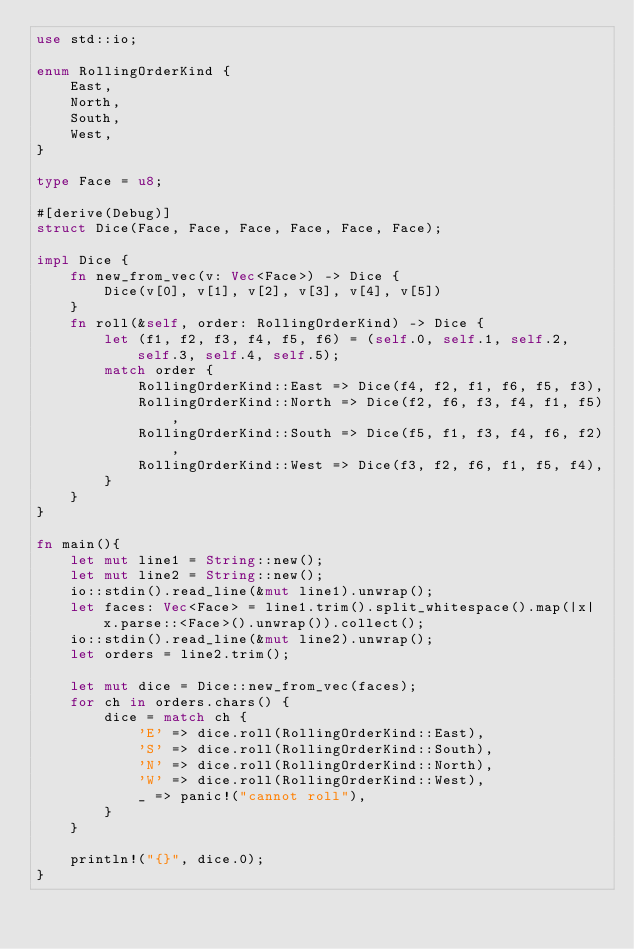<code> <loc_0><loc_0><loc_500><loc_500><_Rust_>use std::io;

enum RollingOrderKind {
    East,
    North,
    South,
    West,
}

type Face = u8;

#[derive(Debug)]
struct Dice(Face, Face, Face, Face, Face, Face);

impl Dice {
    fn new_from_vec(v: Vec<Face>) -> Dice {
        Dice(v[0], v[1], v[2], v[3], v[4], v[5])
    }
    fn roll(&self, order: RollingOrderKind) -> Dice {
        let (f1, f2, f3, f4, f5, f6) = (self.0, self.1, self.2, self.3, self.4, self.5);
        match order {
            RollingOrderKind::East => Dice(f4, f2, f1, f6, f5, f3),
            RollingOrderKind::North => Dice(f2, f6, f3, f4, f1, f5),
            RollingOrderKind::South => Dice(f5, f1, f3, f4, f6, f2),
            RollingOrderKind::West => Dice(f3, f2, f6, f1, f5, f4),
        }
    }
}

fn main(){
    let mut line1 = String::new();
    let mut line2 = String::new();
    io::stdin().read_line(&mut line1).unwrap();
    let faces: Vec<Face> = line1.trim().split_whitespace().map(|x| x.parse::<Face>().unwrap()).collect();
    io::stdin().read_line(&mut line2).unwrap();
    let orders = line2.trim();
    
    let mut dice = Dice::new_from_vec(faces);
    for ch in orders.chars() {
        dice = match ch {
            'E' => dice.roll(RollingOrderKind::East),
            'S' => dice.roll(RollingOrderKind::South),
            'N' => dice.roll(RollingOrderKind::North),
            'W' => dice.roll(RollingOrderKind::West),
            _ => panic!("cannot roll"),
        }
    }
    
    println!("{}", dice.0);
}
</code> 